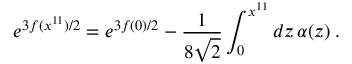Convert formula to latex. <formula><loc_0><loc_0><loc_500><loc_500>e ^ { 3 f ( x ^ { 1 1 } ) / 2 } = e ^ { 3 f ( 0 ) / 2 } - \frac { 1 } { 8 \sqrt { 2 } } \int _ { 0 } ^ { x ^ { 1 1 } } d z \, \alpha ( z ) \, .</formula> 